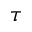Convert formula to latex. <formula><loc_0><loc_0><loc_500><loc_500>\tau</formula> 